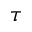Convert formula to latex. <formula><loc_0><loc_0><loc_500><loc_500>\tau</formula> 